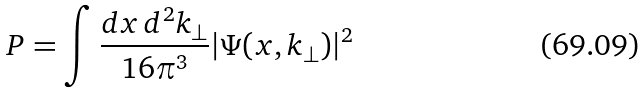Convert formula to latex. <formula><loc_0><loc_0><loc_500><loc_500>P = \int \frac { d x \, d ^ { 2 } k _ { \perp } } { 1 6 \pi ^ { 3 } } | \Psi ( x , k _ { \perp } ) | ^ { 2 }</formula> 